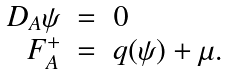<formula> <loc_0><loc_0><loc_500><loc_500>\begin{array} { r l l } D _ { A } \psi & = & 0 \\ F _ { A } ^ { + } & = & q ( \psi ) + \mu . \end{array}</formula> 